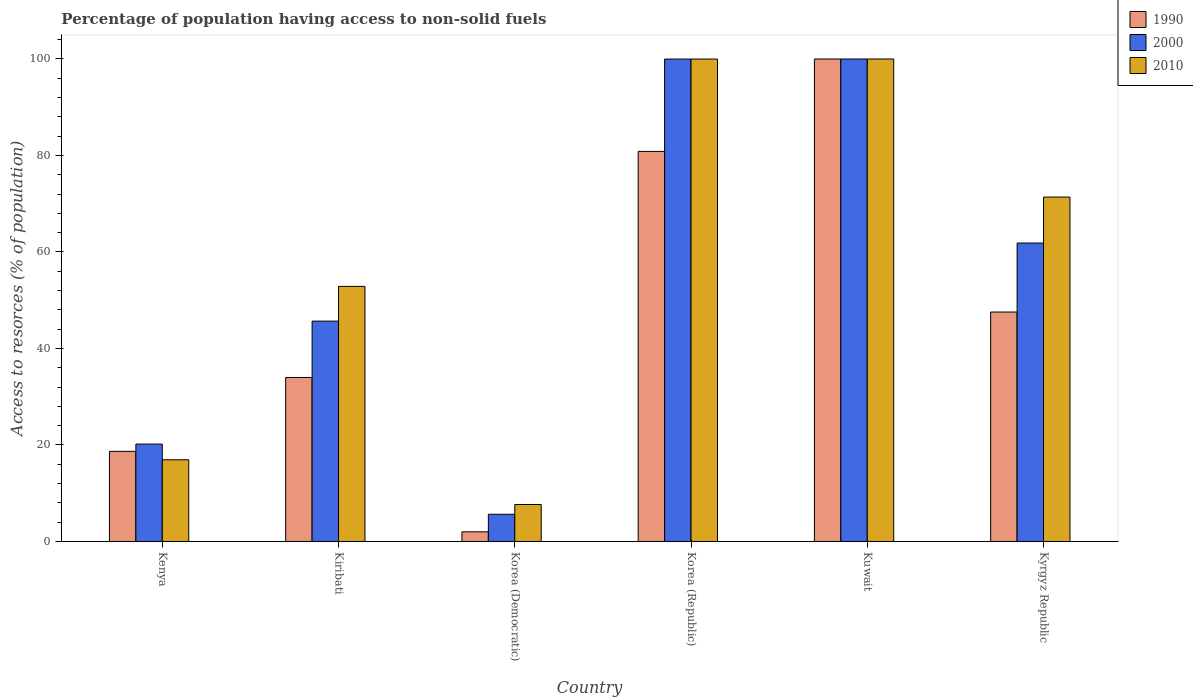How many groups of bars are there?
Keep it short and to the point. 6. Are the number of bars per tick equal to the number of legend labels?
Provide a succinct answer. Yes. Are the number of bars on each tick of the X-axis equal?
Offer a very short reply. Yes. How many bars are there on the 2nd tick from the right?
Give a very brief answer. 3. What is the label of the 4th group of bars from the left?
Provide a short and direct response. Korea (Republic). In how many cases, is the number of bars for a given country not equal to the number of legend labels?
Your answer should be very brief. 0. What is the percentage of population having access to non-solid fuels in 2010 in Korea (Republic)?
Offer a very short reply. 99.99. Across all countries, what is the minimum percentage of population having access to non-solid fuels in 1990?
Provide a succinct answer. 2. In which country was the percentage of population having access to non-solid fuels in 1990 maximum?
Keep it short and to the point. Kuwait. In which country was the percentage of population having access to non-solid fuels in 2000 minimum?
Your response must be concise. Korea (Democratic). What is the total percentage of population having access to non-solid fuels in 1990 in the graph?
Give a very brief answer. 283.07. What is the difference between the percentage of population having access to non-solid fuels in 2000 in Kenya and that in Kiribati?
Keep it short and to the point. -25.48. What is the difference between the percentage of population having access to non-solid fuels in 1990 in Kiribati and the percentage of population having access to non-solid fuels in 2010 in Kuwait?
Your answer should be compact. -66.01. What is the average percentage of population having access to non-solid fuels in 2000 per country?
Your answer should be very brief. 55.56. What is the difference between the percentage of population having access to non-solid fuels of/in 2010 and percentage of population having access to non-solid fuels of/in 2000 in Kenya?
Your response must be concise. -3.25. In how many countries, is the percentage of population having access to non-solid fuels in 1990 greater than 96 %?
Make the answer very short. 1. What is the ratio of the percentage of population having access to non-solid fuels in 2000 in Kenya to that in Kuwait?
Provide a short and direct response. 0.2. Is the percentage of population having access to non-solid fuels in 2010 in Kenya less than that in Kyrgyz Republic?
Provide a short and direct response. Yes. What is the difference between the highest and the second highest percentage of population having access to non-solid fuels in 2010?
Give a very brief answer. -0.01. What is the difference between the highest and the lowest percentage of population having access to non-solid fuels in 2000?
Your answer should be compact. 94.36. What does the 2nd bar from the right in Kuwait represents?
Your answer should be compact. 2000. How many bars are there?
Provide a short and direct response. 18. Are the values on the major ticks of Y-axis written in scientific E-notation?
Give a very brief answer. No. Does the graph contain any zero values?
Provide a short and direct response. No. Does the graph contain grids?
Provide a succinct answer. No. What is the title of the graph?
Your answer should be compact. Percentage of population having access to non-solid fuels. Does "1993" appear as one of the legend labels in the graph?
Keep it short and to the point. No. What is the label or title of the X-axis?
Provide a succinct answer. Country. What is the label or title of the Y-axis?
Offer a terse response. Access to resorces (% of population). What is the Access to resorces (% of population) in 1990 in Kenya?
Make the answer very short. 18.68. What is the Access to resorces (% of population) in 2000 in Kenya?
Ensure brevity in your answer.  20.18. What is the Access to resorces (% of population) of 2010 in Kenya?
Your answer should be very brief. 16.93. What is the Access to resorces (% of population) of 1990 in Kiribati?
Make the answer very short. 33.99. What is the Access to resorces (% of population) in 2000 in Kiribati?
Your answer should be compact. 45.67. What is the Access to resorces (% of population) of 2010 in Kiribati?
Make the answer very short. 52.87. What is the Access to resorces (% of population) of 1990 in Korea (Democratic)?
Provide a succinct answer. 2. What is the Access to resorces (% of population) of 2000 in Korea (Democratic)?
Your answer should be very brief. 5.64. What is the Access to resorces (% of population) of 2010 in Korea (Democratic)?
Your answer should be very brief. 7.67. What is the Access to resorces (% of population) in 1990 in Korea (Republic)?
Ensure brevity in your answer.  80.85. What is the Access to resorces (% of population) in 2000 in Korea (Republic)?
Give a very brief answer. 99.99. What is the Access to resorces (% of population) of 2010 in Korea (Republic)?
Your answer should be compact. 99.99. What is the Access to resorces (% of population) in 1990 in Kuwait?
Offer a terse response. 100. What is the Access to resorces (% of population) of 2000 in Kuwait?
Ensure brevity in your answer.  100. What is the Access to resorces (% of population) of 1990 in Kyrgyz Republic?
Offer a very short reply. 47.55. What is the Access to resorces (% of population) of 2000 in Kyrgyz Republic?
Provide a short and direct response. 61.85. What is the Access to resorces (% of population) in 2010 in Kyrgyz Republic?
Your response must be concise. 71.38. Across all countries, what is the maximum Access to resorces (% of population) in 1990?
Your answer should be very brief. 100. Across all countries, what is the maximum Access to resorces (% of population) of 2010?
Offer a terse response. 100. Across all countries, what is the minimum Access to resorces (% of population) of 1990?
Offer a terse response. 2. Across all countries, what is the minimum Access to resorces (% of population) of 2000?
Offer a very short reply. 5.64. Across all countries, what is the minimum Access to resorces (% of population) of 2010?
Your answer should be compact. 7.67. What is the total Access to resorces (% of population) in 1990 in the graph?
Provide a succinct answer. 283.07. What is the total Access to resorces (% of population) of 2000 in the graph?
Provide a short and direct response. 333.33. What is the total Access to resorces (% of population) in 2010 in the graph?
Keep it short and to the point. 348.85. What is the difference between the Access to resorces (% of population) in 1990 in Kenya and that in Kiribati?
Offer a very short reply. -15.31. What is the difference between the Access to resorces (% of population) in 2000 in Kenya and that in Kiribati?
Keep it short and to the point. -25.48. What is the difference between the Access to resorces (% of population) of 2010 in Kenya and that in Kiribati?
Offer a terse response. -35.94. What is the difference between the Access to resorces (% of population) in 1990 in Kenya and that in Korea (Democratic)?
Offer a terse response. 16.68. What is the difference between the Access to resorces (% of population) in 2000 in Kenya and that in Korea (Democratic)?
Your answer should be compact. 14.55. What is the difference between the Access to resorces (% of population) in 2010 in Kenya and that in Korea (Democratic)?
Offer a terse response. 9.27. What is the difference between the Access to resorces (% of population) of 1990 in Kenya and that in Korea (Republic)?
Provide a short and direct response. -62.17. What is the difference between the Access to resorces (% of population) in 2000 in Kenya and that in Korea (Republic)?
Your answer should be compact. -79.81. What is the difference between the Access to resorces (% of population) in 2010 in Kenya and that in Korea (Republic)?
Make the answer very short. -83.06. What is the difference between the Access to resorces (% of population) of 1990 in Kenya and that in Kuwait?
Make the answer very short. -81.32. What is the difference between the Access to resorces (% of population) of 2000 in Kenya and that in Kuwait?
Provide a short and direct response. -79.82. What is the difference between the Access to resorces (% of population) in 2010 in Kenya and that in Kuwait?
Offer a terse response. -83.07. What is the difference between the Access to resorces (% of population) in 1990 in Kenya and that in Kyrgyz Republic?
Your response must be concise. -28.87. What is the difference between the Access to resorces (% of population) in 2000 in Kenya and that in Kyrgyz Republic?
Ensure brevity in your answer.  -41.67. What is the difference between the Access to resorces (% of population) in 2010 in Kenya and that in Kyrgyz Republic?
Make the answer very short. -54.45. What is the difference between the Access to resorces (% of population) in 1990 in Kiribati and that in Korea (Democratic)?
Provide a short and direct response. 31.99. What is the difference between the Access to resorces (% of population) in 2000 in Kiribati and that in Korea (Democratic)?
Your response must be concise. 40.03. What is the difference between the Access to resorces (% of population) in 2010 in Kiribati and that in Korea (Democratic)?
Offer a terse response. 45.21. What is the difference between the Access to resorces (% of population) in 1990 in Kiribati and that in Korea (Republic)?
Give a very brief answer. -46.86. What is the difference between the Access to resorces (% of population) in 2000 in Kiribati and that in Korea (Republic)?
Provide a short and direct response. -54.32. What is the difference between the Access to resorces (% of population) in 2010 in Kiribati and that in Korea (Republic)?
Provide a succinct answer. -47.12. What is the difference between the Access to resorces (% of population) of 1990 in Kiribati and that in Kuwait?
Offer a terse response. -66.01. What is the difference between the Access to resorces (% of population) in 2000 in Kiribati and that in Kuwait?
Provide a short and direct response. -54.33. What is the difference between the Access to resorces (% of population) in 2010 in Kiribati and that in Kuwait?
Provide a succinct answer. -47.13. What is the difference between the Access to resorces (% of population) in 1990 in Kiribati and that in Kyrgyz Republic?
Offer a terse response. -13.56. What is the difference between the Access to resorces (% of population) of 2000 in Kiribati and that in Kyrgyz Republic?
Make the answer very short. -16.19. What is the difference between the Access to resorces (% of population) in 2010 in Kiribati and that in Kyrgyz Republic?
Your answer should be compact. -18.51. What is the difference between the Access to resorces (% of population) of 1990 in Korea (Democratic) and that in Korea (Republic)?
Provide a short and direct response. -78.85. What is the difference between the Access to resorces (% of population) in 2000 in Korea (Democratic) and that in Korea (Republic)?
Offer a terse response. -94.35. What is the difference between the Access to resorces (% of population) in 2010 in Korea (Democratic) and that in Korea (Republic)?
Give a very brief answer. -92.32. What is the difference between the Access to resorces (% of population) of 1990 in Korea (Democratic) and that in Kuwait?
Your response must be concise. -98. What is the difference between the Access to resorces (% of population) in 2000 in Korea (Democratic) and that in Kuwait?
Provide a short and direct response. -94.36. What is the difference between the Access to resorces (% of population) of 2010 in Korea (Democratic) and that in Kuwait?
Your answer should be compact. -92.33. What is the difference between the Access to resorces (% of population) of 1990 in Korea (Democratic) and that in Kyrgyz Republic?
Your answer should be very brief. -45.55. What is the difference between the Access to resorces (% of population) of 2000 in Korea (Democratic) and that in Kyrgyz Republic?
Give a very brief answer. -56.22. What is the difference between the Access to resorces (% of population) in 2010 in Korea (Democratic) and that in Kyrgyz Republic?
Keep it short and to the point. -63.72. What is the difference between the Access to resorces (% of population) in 1990 in Korea (Republic) and that in Kuwait?
Make the answer very short. -19.15. What is the difference between the Access to resorces (% of population) of 2000 in Korea (Republic) and that in Kuwait?
Your response must be concise. -0.01. What is the difference between the Access to resorces (% of population) of 2010 in Korea (Republic) and that in Kuwait?
Your answer should be very brief. -0.01. What is the difference between the Access to resorces (% of population) in 1990 in Korea (Republic) and that in Kyrgyz Republic?
Give a very brief answer. 33.3. What is the difference between the Access to resorces (% of population) in 2000 in Korea (Republic) and that in Kyrgyz Republic?
Provide a succinct answer. 38.14. What is the difference between the Access to resorces (% of population) of 2010 in Korea (Republic) and that in Kyrgyz Republic?
Offer a terse response. 28.61. What is the difference between the Access to resorces (% of population) in 1990 in Kuwait and that in Kyrgyz Republic?
Keep it short and to the point. 52.45. What is the difference between the Access to resorces (% of population) in 2000 in Kuwait and that in Kyrgyz Republic?
Give a very brief answer. 38.15. What is the difference between the Access to resorces (% of population) of 2010 in Kuwait and that in Kyrgyz Republic?
Your answer should be compact. 28.62. What is the difference between the Access to resorces (% of population) in 1990 in Kenya and the Access to resorces (% of population) in 2000 in Kiribati?
Provide a succinct answer. -26.99. What is the difference between the Access to resorces (% of population) in 1990 in Kenya and the Access to resorces (% of population) in 2010 in Kiribati?
Give a very brief answer. -34.19. What is the difference between the Access to resorces (% of population) in 2000 in Kenya and the Access to resorces (% of population) in 2010 in Kiribati?
Provide a succinct answer. -32.69. What is the difference between the Access to resorces (% of population) in 1990 in Kenya and the Access to resorces (% of population) in 2000 in Korea (Democratic)?
Offer a terse response. 13.04. What is the difference between the Access to resorces (% of population) in 1990 in Kenya and the Access to resorces (% of population) in 2010 in Korea (Democratic)?
Provide a short and direct response. 11.01. What is the difference between the Access to resorces (% of population) of 2000 in Kenya and the Access to resorces (% of population) of 2010 in Korea (Democratic)?
Make the answer very short. 12.52. What is the difference between the Access to resorces (% of population) of 1990 in Kenya and the Access to resorces (% of population) of 2000 in Korea (Republic)?
Your answer should be very brief. -81.31. What is the difference between the Access to resorces (% of population) of 1990 in Kenya and the Access to resorces (% of population) of 2010 in Korea (Republic)?
Offer a very short reply. -81.31. What is the difference between the Access to resorces (% of population) in 2000 in Kenya and the Access to resorces (% of population) in 2010 in Korea (Republic)?
Your answer should be compact. -79.81. What is the difference between the Access to resorces (% of population) in 1990 in Kenya and the Access to resorces (% of population) in 2000 in Kuwait?
Keep it short and to the point. -81.32. What is the difference between the Access to resorces (% of population) of 1990 in Kenya and the Access to resorces (% of population) of 2010 in Kuwait?
Provide a succinct answer. -81.32. What is the difference between the Access to resorces (% of population) of 2000 in Kenya and the Access to resorces (% of population) of 2010 in Kuwait?
Give a very brief answer. -79.82. What is the difference between the Access to resorces (% of population) of 1990 in Kenya and the Access to resorces (% of population) of 2000 in Kyrgyz Republic?
Offer a terse response. -43.18. What is the difference between the Access to resorces (% of population) in 1990 in Kenya and the Access to resorces (% of population) in 2010 in Kyrgyz Republic?
Ensure brevity in your answer.  -52.71. What is the difference between the Access to resorces (% of population) of 2000 in Kenya and the Access to resorces (% of population) of 2010 in Kyrgyz Republic?
Provide a short and direct response. -51.2. What is the difference between the Access to resorces (% of population) of 1990 in Kiribati and the Access to resorces (% of population) of 2000 in Korea (Democratic)?
Provide a succinct answer. 28.35. What is the difference between the Access to resorces (% of population) of 1990 in Kiribati and the Access to resorces (% of population) of 2010 in Korea (Democratic)?
Give a very brief answer. 26.32. What is the difference between the Access to resorces (% of population) of 2000 in Kiribati and the Access to resorces (% of population) of 2010 in Korea (Democratic)?
Ensure brevity in your answer.  38. What is the difference between the Access to resorces (% of population) in 1990 in Kiribati and the Access to resorces (% of population) in 2000 in Korea (Republic)?
Provide a succinct answer. -66. What is the difference between the Access to resorces (% of population) of 1990 in Kiribati and the Access to resorces (% of population) of 2010 in Korea (Republic)?
Ensure brevity in your answer.  -66. What is the difference between the Access to resorces (% of population) in 2000 in Kiribati and the Access to resorces (% of population) in 2010 in Korea (Republic)?
Your answer should be very brief. -54.32. What is the difference between the Access to resorces (% of population) in 1990 in Kiribati and the Access to resorces (% of population) in 2000 in Kuwait?
Give a very brief answer. -66.01. What is the difference between the Access to resorces (% of population) of 1990 in Kiribati and the Access to resorces (% of population) of 2010 in Kuwait?
Keep it short and to the point. -66.01. What is the difference between the Access to resorces (% of population) in 2000 in Kiribati and the Access to resorces (% of population) in 2010 in Kuwait?
Your answer should be very brief. -54.33. What is the difference between the Access to resorces (% of population) of 1990 in Kiribati and the Access to resorces (% of population) of 2000 in Kyrgyz Republic?
Keep it short and to the point. -27.86. What is the difference between the Access to resorces (% of population) in 1990 in Kiribati and the Access to resorces (% of population) in 2010 in Kyrgyz Republic?
Make the answer very short. -37.39. What is the difference between the Access to resorces (% of population) of 2000 in Kiribati and the Access to resorces (% of population) of 2010 in Kyrgyz Republic?
Offer a terse response. -25.72. What is the difference between the Access to resorces (% of population) of 1990 in Korea (Democratic) and the Access to resorces (% of population) of 2000 in Korea (Republic)?
Make the answer very short. -97.99. What is the difference between the Access to resorces (% of population) of 1990 in Korea (Democratic) and the Access to resorces (% of population) of 2010 in Korea (Republic)?
Make the answer very short. -97.99. What is the difference between the Access to resorces (% of population) of 2000 in Korea (Democratic) and the Access to resorces (% of population) of 2010 in Korea (Republic)?
Ensure brevity in your answer.  -94.35. What is the difference between the Access to resorces (% of population) of 1990 in Korea (Democratic) and the Access to resorces (% of population) of 2000 in Kuwait?
Offer a terse response. -98. What is the difference between the Access to resorces (% of population) of 1990 in Korea (Democratic) and the Access to resorces (% of population) of 2010 in Kuwait?
Your answer should be very brief. -98. What is the difference between the Access to resorces (% of population) of 2000 in Korea (Democratic) and the Access to resorces (% of population) of 2010 in Kuwait?
Provide a succinct answer. -94.36. What is the difference between the Access to resorces (% of population) in 1990 in Korea (Democratic) and the Access to resorces (% of population) in 2000 in Kyrgyz Republic?
Give a very brief answer. -59.85. What is the difference between the Access to resorces (% of population) in 1990 in Korea (Democratic) and the Access to resorces (% of population) in 2010 in Kyrgyz Republic?
Make the answer very short. -69.38. What is the difference between the Access to resorces (% of population) in 2000 in Korea (Democratic) and the Access to resorces (% of population) in 2010 in Kyrgyz Republic?
Your response must be concise. -65.75. What is the difference between the Access to resorces (% of population) in 1990 in Korea (Republic) and the Access to resorces (% of population) in 2000 in Kuwait?
Give a very brief answer. -19.15. What is the difference between the Access to resorces (% of population) in 1990 in Korea (Republic) and the Access to resorces (% of population) in 2010 in Kuwait?
Provide a succinct answer. -19.15. What is the difference between the Access to resorces (% of population) of 2000 in Korea (Republic) and the Access to resorces (% of population) of 2010 in Kuwait?
Offer a terse response. -0.01. What is the difference between the Access to resorces (% of population) in 1990 in Korea (Republic) and the Access to resorces (% of population) in 2000 in Kyrgyz Republic?
Keep it short and to the point. 18.99. What is the difference between the Access to resorces (% of population) in 1990 in Korea (Republic) and the Access to resorces (% of population) in 2010 in Kyrgyz Republic?
Keep it short and to the point. 9.46. What is the difference between the Access to resorces (% of population) of 2000 in Korea (Republic) and the Access to resorces (% of population) of 2010 in Kyrgyz Republic?
Make the answer very short. 28.61. What is the difference between the Access to resorces (% of population) of 1990 in Kuwait and the Access to resorces (% of population) of 2000 in Kyrgyz Republic?
Your response must be concise. 38.15. What is the difference between the Access to resorces (% of population) of 1990 in Kuwait and the Access to resorces (% of population) of 2010 in Kyrgyz Republic?
Ensure brevity in your answer.  28.62. What is the difference between the Access to resorces (% of population) in 2000 in Kuwait and the Access to resorces (% of population) in 2010 in Kyrgyz Republic?
Give a very brief answer. 28.62. What is the average Access to resorces (% of population) in 1990 per country?
Give a very brief answer. 47.18. What is the average Access to resorces (% of population) of 2000 per country?
Offer a terse response. 55.56. What is the average Access to resorces (% of population) in 2010 per country?
Make the answer very short. 58.14. What is the difference between the Access to resorces (% of population) of 1990 and Access to resorces (% of population) of 2000 in Kenya?
Provide a succinct answer. -1.51. What is the difference between the Access to resorces (% of population) of 1990 and Access to resorces (% of population) of 2010 in Kenya?
Make the answer very short. 1.74. What is the difference between the Access to resorces (% of population) in 2000 and Access to resorces (% of population) in 2010 in Kenya?
Offer a very short reply. 3.25. What is the difference between the Access to resorces (% of population) of 1990 and Access to resorces (% of population) of 2000 in Kiribati?
Your response must be concise. -11.68. What is the difference between the Access to resorces (% of population) in 1990 and Access to resorces (% of population) in 2010 in Kiribati?
Your answer should be very brief. -18.88. What is the difference between the Access to resorces (% of population) in 2000 and Access to resorces (% of population) in 2010 in Kiribati?
Ensure brevity in your answer.  -7.2. What is the difference between the Access to resorces (% of population) of 1990 and Access to resorces (% of population) of 2000 in Korea (Democratic)?
Your answer should be compact. -3.64. What is the difference between the Access to resorces (% of population) of 1990 and Access to resorces (% of population) of 2010 in Korea (Democratic)?
Ensure brevity in your answer.  -5.67. What is the difference between the Access to resorces (% of population) in 2000 and Access to resorces (% of population) in 2010 in Korea (Democratic)?
Provide a succinct answer. -2.03. What is the difference between the Access to resorces (% of population) of 1990 and Access to resorces (% of population) of 2000 in Korea (Republic)?
Provide a short and direct response. -19.14. What is the difference between the Access to resorces (% of population) of 1990 and Access to resorces (% of population) of 2010 in Korea (Republic)?
Keep it short and to the point. -19.14. What is the difference between the Access to resorces (% of population) of 1990 and Access to resorces (% of population) of 2000 in Kuwait?
Your answer should be compact. 0. What is the difference between the Access to resorces (% of population) in 1990 and Access to resorces (% of population) in 2010 in Kuwait?
Your response must be concise. 0. What is the difference between the Access to resorces (% of population) in 2000 and Access to resorces (% of population) in 2010 in Kuwait?
Provide a short and direct response. 0. What is the difference between the Access to resorces (% of population) of 1990 and Access to resorces (% of population) of 2000 in Kyrgyz Republic?
Offer a terse response. -14.3. What is the difference between the Access to resorces (% of population) in 1990 and Access to resorces (% of population) in 2010 in Kyrgyz Republic?
Your response must be concise. -23.83. What is the difference between the Access to resorces (% of population) of 2000 and Access to resorces (% of population) of 2010 in Kyrgyz Republic?
Your answer should be very brief. -9.53. What is the ratio of the Access to resorces (% of population) of 1990 in Kenya to that in Kiribati?
Keep it short and to the point. 0.55. What is the ratio of the Access to resorces (% of population) in 2000 in Kenya to that in Kiribati?
Provide a succinct answer. 0.44. What is the ratio of the Access to resorces (% of population) of 2010 in Kenya to that in Kiribati?
Offer a terse response. 0.32. What is the ratio of the Access to resorces (% of population) of 1990 in Kenya to that in Korea (Democratic)?
Ensure brevity in your answer.  9.34. What is the ratio of the Access to resorces (% of population) in 2000 in Kenya to that in Korea (Democratic)?
Offer a very short reply. 3.58. What is the ratio of the Access to resorces (% of population) in 2010 in Kenya to that in Korea (Democratic)?
Offer a very short reply. 2.21. What is the ratio of the Access to resorces (% of population) of 1990 in Kenya to that in Korea (Republic)?
Offer a very short reply. 0.23. What is the ratio of the Access to resorces (% of population) in 2000 in Kenya to that in Korea (Republic)?
Provide a succinct answer. 0.2. What is the ratio of the Access to resorces (% of population) in 2010 in Kenya to that in Korea (Republic)?
Your answer should be compact. 0.17. What is the ratio of the Access to resorces (% of population) in 1990 in Kenya to that in Kuwait?
Offer a terse response. 0.19. What is the ratio of the Access to resorces (% of population) of 2000 in Kenya to that in Kuwait?
Offer a terse response. 0.2. What is the ratio of the Access to resorces (% of population) of 2010 in Kenya to that in Kuwait?
Your answer should be very brief. 0.17. What is the ratio of the Access to resorces (% of population) of 1990 in Kenya to that in Kyrgyz Republic?
Provide a short and direct response. 0.39. What is the ratio of the Access to resorces (% of population) of 2000 in Kenya to that in Kyrgyz Republic?
Offer a very short reply. 0.33. What is the ratio of the Access to resorces (% of population) in 2010 in Kenya to that in Kyrgyz Republic?
Give a very brief answer. 0.24. What is the ratio of the Access to resorces (% of population) of 1990 in Kiribati to that in Korea (Democratic)?
Give a very brief answer. 17. What is the ratio of the Access to resorces (% of population) in 2000 in Kiribati to that in Korea (Democratic)?
Make the answer very short. 8.1. What is the ratio of the Access to resorces (% of population) in 2010 in Kiribati to that in Korea (Democratic)?
Your answer should be very brief. 6.9. What is the ratio of the Access to resorces (% of population) in 1990 in Kiribati to that in Korea (Republic)?
Ensure brevity in your answer.  0.42. What is the ratio of the Access to resorces (% of population) of 2000 in Kiribati to that in Korea (Republic)?
Offer a terse response. 0.46. What is the ratio of the Access to resorces (% of population) of 2010 in Kiribati to that in Korea (Republic)?
Provide a succinct answer. 0.53. What is the ratio of the Access to resorces (% of population) of 1990 in Kiribati to that in Kuwait?
Your answer should be very brief. 0.34. What is the ratio of the Access to resorces (% of population) in 2000 in Kiribati to that in Kuwait?
Your answer should be very brief. 0.46. What is the ratio of the Access to resorces (% of population) of 2010 in Kiribati to that in Kuwait?
Your answer should be very brief. 0.53. What is the ratio of the Access to resorces (% of population) of 1990 in Kiribati to that in Kyrgyz Republic?
Your answer should be compact. 0.71. What is the ratio of the Access to resorces (% of population) in 2000 in Kiribati to that in Kyrgyz Republic?
Ensure brevity in your answer.  0.74. What is the ratio of the Access to resorces (% of population) in 2010 in Kiribati to that in Kyrgyz Republic?
Give a very brief answer. 0.74. What is the ratio of the Access to resorces (% of population) in 1990 in Korea (Democratic) to that in Korea (Republic)?
Provide a short and direct response. 0.02. What is the ratio of the Access to resorces (% of population) in 2000 in Korea (Democratic) to that in Korea (Republic)?
Ensure brevity in your answer.  0.06. What is the ratio of the Access to resorces (% of population) in 2010 in Korea (Democratic) to that in Korea (Republic)?
Keep it short and to the point. 0.08. What is the ratio of the Access to resorces (% of population) of 1990 in Korea (Democratic) to that in Kuwait?
Make the answer very short. 0.02. What is the ratio of the Access to resorces (% of population) in 2000 in Korea (Democratic) to that in Kuwait?
Ensure brevity in your answer.  0.06. What is the ratio of the Access to resorces (% of population) of 2010 in Korea (Democratic) to that in Kuwait?
Provide a succinct answer. 0.08. What is the ratio of the Access to resorces (% of population) of 1990 in Korea (Democratic) to that in Kyrgyz Republic?
Provide a short and direct response. 0.04. What is the ratio of the Access to resorces (% of population) of 2000 in Korea (Democratic) to that in Kyrgyz Republic?
Offer a very short reply. 0.09. What is the ratio of the Access to resorces (% of population) of 2010 in Korea (Democratic) to that in Kyrgyz Republic?
Offer a very short reply. 0.11. What is the ratio of the Access to resorces (% of population) of 1990 in Korea (Republic) to that in Kuwait?
Your response must be concise. 0.81. What is the ratio of the Access to resorces (% of population) of 2010 in Korea (Republic) to that in Kuwait?
Your answer should be compact. 1. What is the ratio of the Access to resorces (% of population) of 1990 in Korea (Republic) to that in Kyrgyz Republic?
Your answer should be compact. 1.7. What is the ratio of the Access to resorces (% of population) of 2000 in Korea (Republic) to that in Kyrgyz Republic?
Provide a succinct answer. 1.62. What is the ratio of the Access to resorces (% of population) in 2010 in Korea (Republic) to that in Kyrgyz Republic?
Your answer should be compact. 1.4. What is the ratio of the Access to resorces (% of population) in 1990 in Kuwait to that in Kyrgyz Republic?
Offer a very short reply. 2.1. What is the ratio of the Access to resorces (% of population) in 2000 in Kuwait to that in Kyrgyz Republic?
Offer a terse response. 1.62. What is the ratio of the Access to resorces (% of population) of 2010 in Kuwait to that in Kyrgyz Republic?
Offer a terse response. 1.4. What is the difference between the highest and the second highest Access to resorces (% of population) of 1990?
Keep it short and to the point. 19.15. What is the difference between the highest and the second highest Access to resorces (% of population) of 2010?
Provide a short and direct response. 0.01. What is the difference between the highest and the lowest Access to resorces (% of population) of 1990?
Provide a succinct answer. 98. What is the difference between the highest and the lowest Access to resorces (% of population) of 2000?
Offer a very short reply. 94.36. What is the difference between the highest and the lowest Access to resorces (% of population) of 2010?
Your response must be concise. 92.33. 